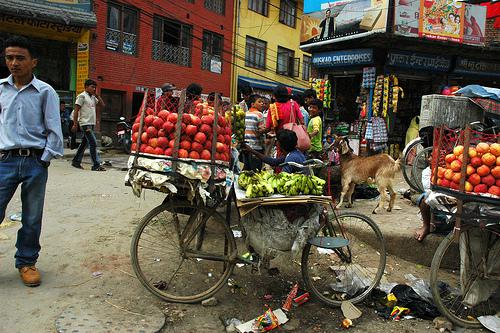Question: what is this a photo of?
Choices:
A. A city bazaar.
B. A festival.
C. A parade.
D. Shops.
Answer with the letter. Answer: A Question: who is in the photo?
Choices:
A. Tourists.
B. City inhabitants.
C. Children.
D. Shop owners.
Answer with the letter. Answer: B Question: what type of pants does the man have on?
Choices:
A. Blue jeans.
B. Black pants.
C. Shorts.
D. Dress pants.
Answer with the letter. Answer: A Question: what animal is in the background?
Choices:
A. A cat.
B. A bird.
C. A dog.
D. A cow.
Answer with the letter. Answer: C Question: what color are the bananas?
Choices:
A. Yellowish-green.
B. Greenish-yellow.
C. Yellow.
D. Green.
Answer with the letter. Answer: B 